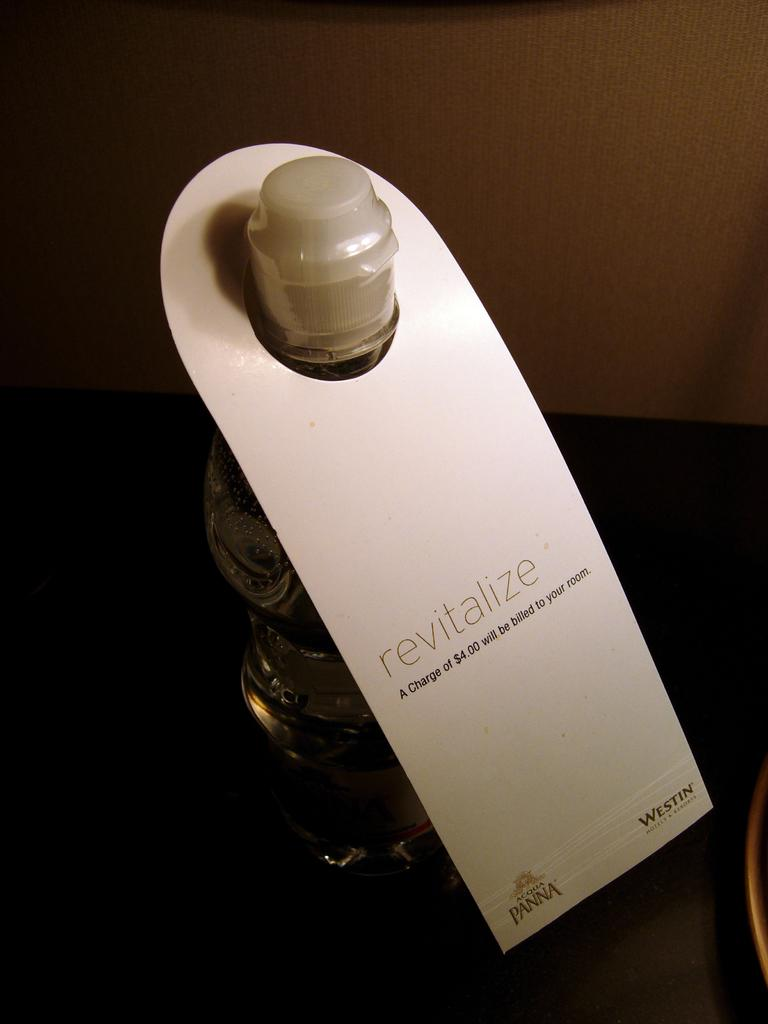What type of container is visible in the image? There is a glass bottle in the image. What is the name of the bottle? The bottle is named "revitalize." How many clocks are hanging on the wall behind the bottle in the image? There are no clocks visible in the image; it only features a glass bottle named "revitalize." 